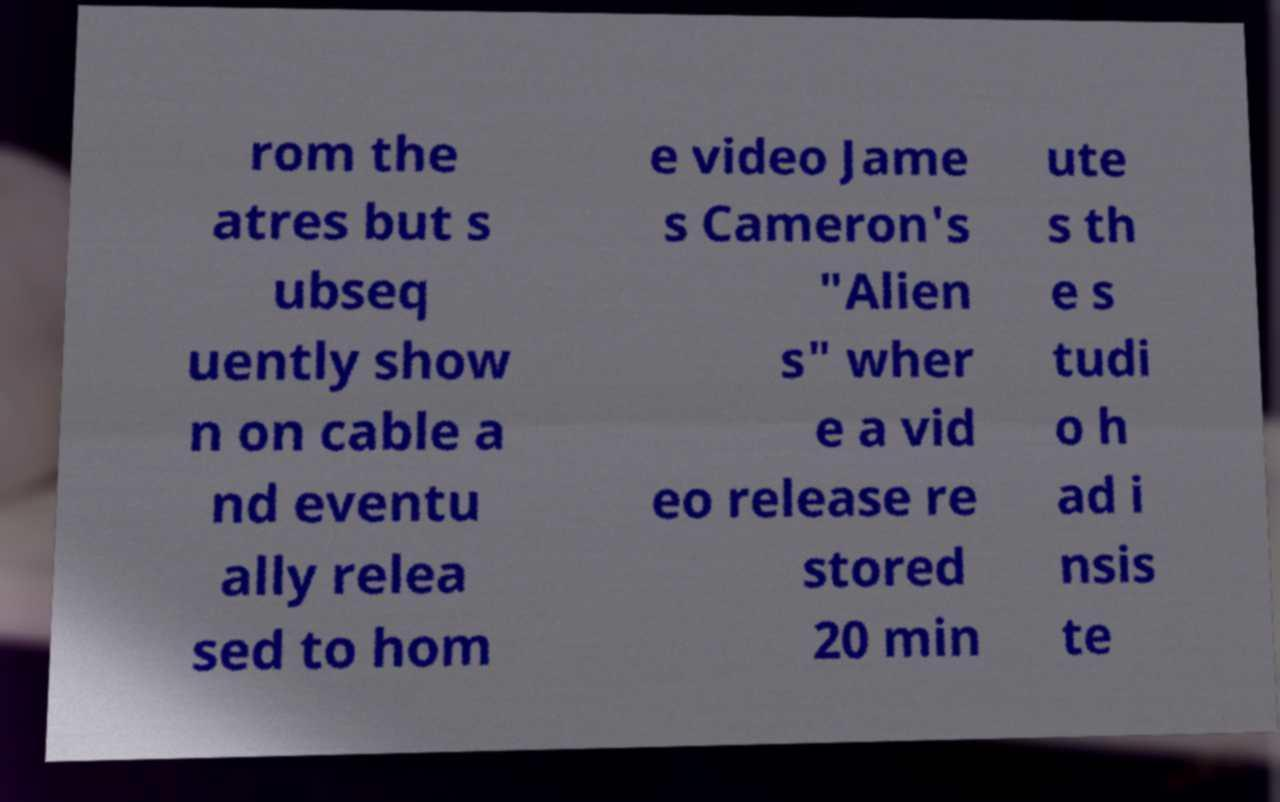Can you accurately transcribe the text from the provided image for me? rom the atres but s ubseq uently show n on cable a nd eventu ally relea sed to hom e video Jame s Cameron's "Alien s" wher e a vid eo release re stored 20 min ute s th e s tudi o h ad i nsis te 